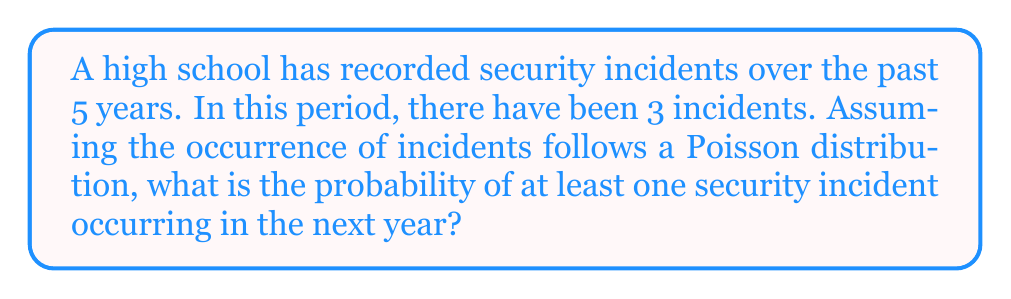Provide a solution to this math problem. To solve this problem, we'll follow these steps:

1) First, we need to calculate the average rate (λ) of incidents per year:
   $\lambda = \frac{\text{Total incidents}}{\text{Number of years}} = \frac{3}{5} = 0.6$ incidents/year

2) We're looking for the probability of at least one incident in the next year. This is equivalent to 1 minus the probability of zero incidents.

3) The Poisson distribution gives the probability of x events in a given time period:

   $$P(X = x) = \frac{e^{-\lambda}\lambda^x}{x!}$$

4) For zero incidents (x = 0):

   $$P(X = 0) = \frac{e^{-0.6}(0.6)^0}{0!} = e^{-0.6} \approx 0.5488$$

5) Therefore, the probability of at least one incident is:

   $$P(X \geq 1) = 1 - P(X = 0) = 1 - e^{-0.6} \approx 1 - 0.5488 = 0.4512$$

6) Convert to a percentage: 0.4512 * 100 ≈ 45.12%
Answer: 45.12% 